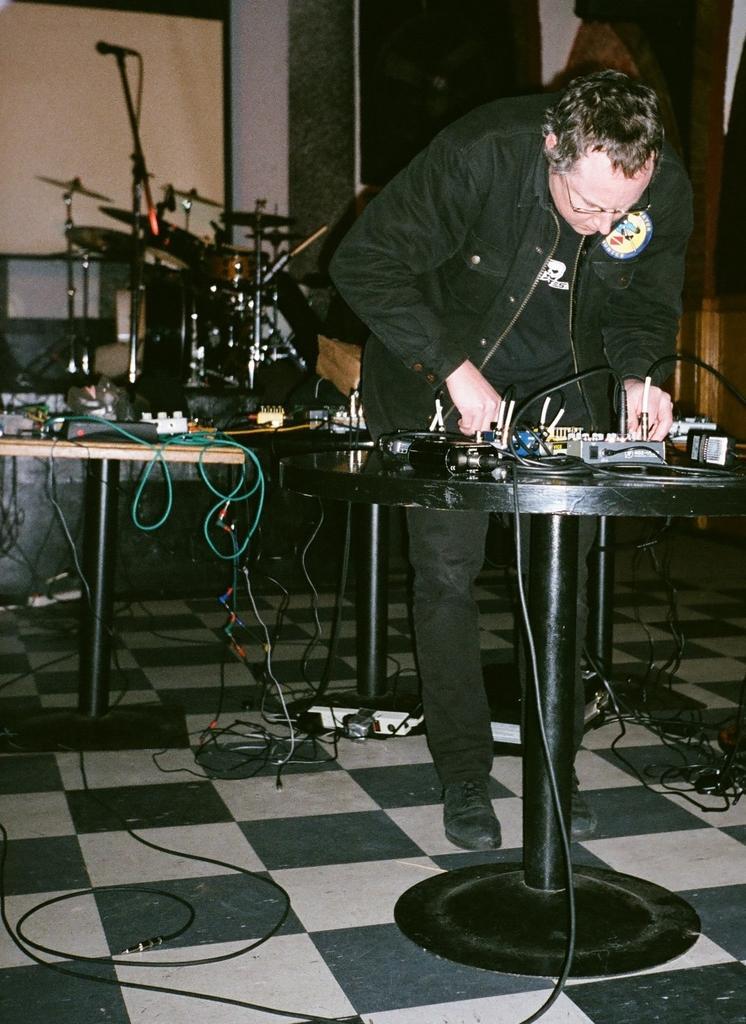Describe this image in one or two sentences. In this image there is a person standing on the floor. In front of him there is a table. On top of it there are some objects. Behind him there are tables. On top of it there are a few objects. At the bottom of the image there are cables on the floor. In the background of the image there are some musical instruments. There is a screen and a wall. 